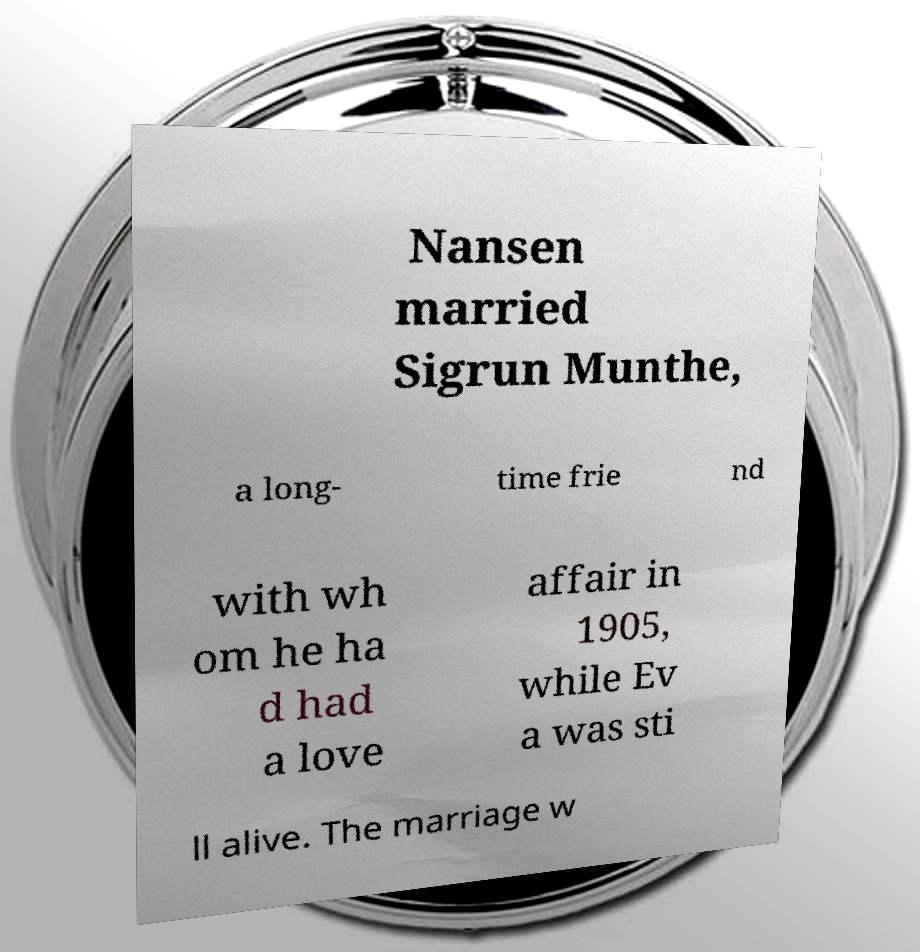Could you extract and type out the text from this image? Nansen married Sigrun Munthe, a long- time frie nd with wh om he ha d had a love affair in 1905, while Ev a was sti ll alive. The marriage w 